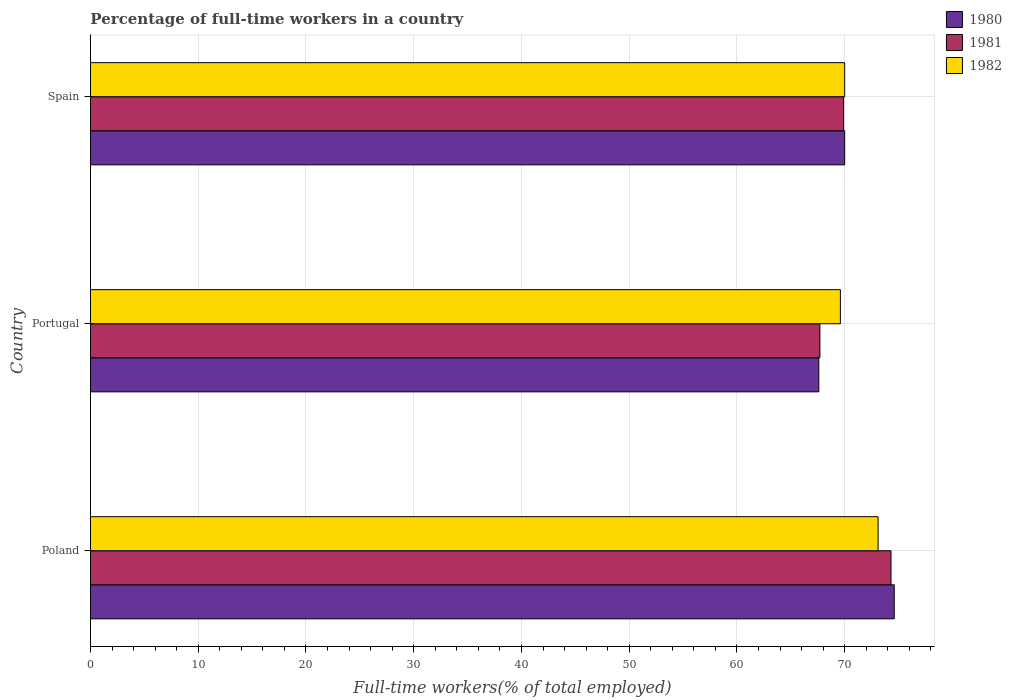How many bars are there on the 3rd tick from the bottom?
Keep it short and to the point. 3. Across all countries, what is the maximum percentage of full-time workers in 1982?
Provide a succinct answer. 73.1. Across all countries, what is the minimum percentage of full-time workers in 1982?
Provide a short and direct response. 69.6. What is the total percentage of full-time workers in 1981 in the graph?
Offer a terse response. 211.9. What is the difference between the percentage of full-time workers in 1981 in Poland and that in Portugal?
Make the answer very short. 6.6. What is the difference between the percentage of full-time workers in 1981 in Poland and the percentage of full-time workers in 1980 in Spain?
Provide a succinct answer. 4.3. What is the average percentage of full-time workers in 1981 per country?
Provide a short and direct response. 70.63. What is the difference between the percentage of full-time workers in 1980 and percentage of full-time workers in 1981 in Spain?
Offer a very short reply. 0.1. In how many countries, is the percentage of full-time workers in 1981 greater than 20 %?
Make the answer very short. 3. What is the ratio of the percentage of full-time workers in 1980 in Portugal to that in Spain?
Give a very brief answer. 0.97. Is the percentage of full-time workers in 1980 in Poland less than that in Spain?
Keep it short and to the point. No. What is the difference between the highest and the second highest percentage of full-time workers in 1980?
Provide a short and direct response. 4.6. What is the difference between the highest and the lowest percentage of full-time workers in 1982?
Make the answer very short. 3.5. In how many countries, is the percentage of full-time workers in 1982 greater than the average percentage of full-time workers in 1982 taken over all countries?
Provide a short and direct response. 1. What does the 1st bar from the top in Poland represents?
Keep it short and to the point. 1982. Are the values on the major ticks of X-axis written in scientific E-notation?
Keep it short and to the point. No. Does the graph contain any zero values?
Keep it short and to the point. No. How many legend labels are there?
Keep it short and to the point. 3. What is the title of the graph?
Offer a terse response. Percentage of full-time workers in a country. What is the label or title of the X-axis?
Keep it short and to the point. Full-time workers(% of total employed). What is the Full-time workers(% of total employed) in 1980 in Poland?
Offer a terse response. 74.6. What is the Full-time workers(% of total employed) of 1981 in Poland?
Keep it short and to the point. 74.3. What is the Full-time workers(% of total employed) in 1982 in Poland?
Offer a very short reply. 73.1. What is the Full-time workers(% of total employed) of 1980 in Portugal?
Ensure brevity in your answer.  67.6. What is the Full-time workers(% of total employed) in 1981 in Portugal?
Your response must be concise. 67.7. What is the Full-time workers(% of total employed) of 1982 in Portugal?
Your response must be concise. 69.6. What is the Full-time workers(% of total employed) in 1980 in Spain?
Offer a terse response. 70. What is the Full-time workers(% of total employed) in 1981 in Spain?
Your answer should be very brief. 69.9. Across all countries, what is the maximum Full-time workers(% of total employed) in 1980?
Give a very brief answer. 74.6. Across all countries, what is the maximum Full-time workers(% of total employed) of 1981?
Make the answer very short. 74.3. Across all countries, what is the maximum Full-time workers(% of total employed) in 1982?
Give a very brief answer. 73.1. Across all countries, what is the minimum Full-time workers(% of total employed) of 1980?
Offer a very short reply. 67.6. Across all countries, what is the minimum Full-time workers(% of total employed) of 1981?
Provide a succinct answer. 67.7. Across all countries, what is the minimum Full-time workers(% of total employed) of 1982?
Your answer should be very brief. 69.6. What is the total Full-time workers(% of total employed) in 1980 in the graph?
Provide a short and direct response. 212.2. What is the total Full-time workers(% of total employed) of 1981 in the graph?
Ensure brevity in your answer.  211.9. What is the total Full-time workers(% of total employed) in 1982 in the graph?
Your answer should be compact. 212.7. What is the difference between the Full-time workers(% of total employed) of 1981 in Poland and that in Portugal?
Ensure brevity in your answer.  6.6. What is the difference between the Full-time workers(% of total employed) of 1982 in Poland and that in Portugal?
Provide a succinct answer. 3.5. What is the difference between the Full-time workers(% of total employed) of 1980 in Poland and that in Spain?
Give a very brief answer. 4.6. What is the difference between the Full-time workers(% of total employed) of 1982 in Portugal and that in Spain?
Ensure brevity in your answer.  -0.4. What is the difference between the Full-time workers(% of total employed) of 1980 in Poland and the Full-time workers(% of total employed) of 1981 in Portugal?
Your response must be concise. 6.9. What is the difference between the Full-time workers(% of total employed) of 1981 in Poland and the Full-time workers(% of total employed) of 1982 in Portugal?
Give a very brief answer. 4.7. What is the difference between the Full-time workers(% of total employed) of 1980 in Poland and the Full-time workers(% of total employed) of 1981 in Spain?
Offer a terse response. 4.7. What is the difference between the Full-time workers(% of total employed) of 1981 in Portugal and the Full-time workers(% of total employed) of 1982 in Spain?
Your answer should be compact. -2.3. What is the average Full-time workers(% of total employed) of 1980 per country?
Your answer should be compact. 70.73. What is the average Full-time workers(% of total employed) in 1981 per country?
Ensure brevity in your answer.  70.63. What is the average Full-time workers(% of total employed) of 1982 per country?
Provide a succinct answer. 70.9. What is the difference between the Full-time workers(% of total employed) in 1980 and Full-time workers(% of total employed) in 1982 in Poland?
Give a very brief answer. 1.5. What is the difference between the Full-time workers(% of total employed) of 1981 and Full-time workers(% of total employed) of 1982 in Portugal?
Give a very brief answer. -1.9. What is the difference between the Full-time workers(% of total employed) in 1980 and Full-time workers(% of total employed) in 1981 in Spain?
Ensure brevity in your answer.  0.1. What is the difference between the Full-time workers(% of total employed) in 1980 and Full-time workers(% of total employed) in 1982 in Spain?
Provide a short and direct response. 0. What is the ratio of the Full-time workers(% of total employed) in 1980 in Poland to that in Portugal?
Provide a succinct answer. 1.1. What is the ratio of the Full-time workers(% of total employed) in 1981 in Poland to that in Portugal?
Keep it short and to the point. 1.1. What is the ratio of the Full-time workers(% of total employed) of 1982 in Poland to that in Portugal?
Keep it short and to the point. 1.05. What is the ratio of the Full-time workers(% of total employed) of 1980 in Poland to that in Spain?
Keep it short and to the point. 1.07. What is the ratio of the Full-time workers(% of total employed) of 1981 in Poland to that in Spain?
Your answer should be very brief. 1.06. What is the ratio of the Full-time workers(% of total employed) in 1982 in Poland to that in Spain?
Ensure brevity in your answer.  1.04. What is the ratio of the Full-time workers(% of total employed) in 1980 in Portugal to that in Spain?
Offer a very short reply. 0.97. What is the ratio of the Full-time workers(% of total employed) in 1981 in Portugal to that in Spain?
Offer a terse response. 0.97. What is the difference between the highest and the second highest Full-time workers(% of total employed) of 1980?
Offer a terse response. 4.6. What is the difference between the highest and the second highest Full-time workers(% of total employed) of 1981?
Keep it short and to the point. 4.4. What is the difference between the highest and the second highest Full-time workers(% of total employed) in 1982?
Provide a short and direct response. 3.1. What is the difference between the highest and the lowest Full-time workers(% of total employed) of 1982?
Provide a succinct answer. 3.5. 